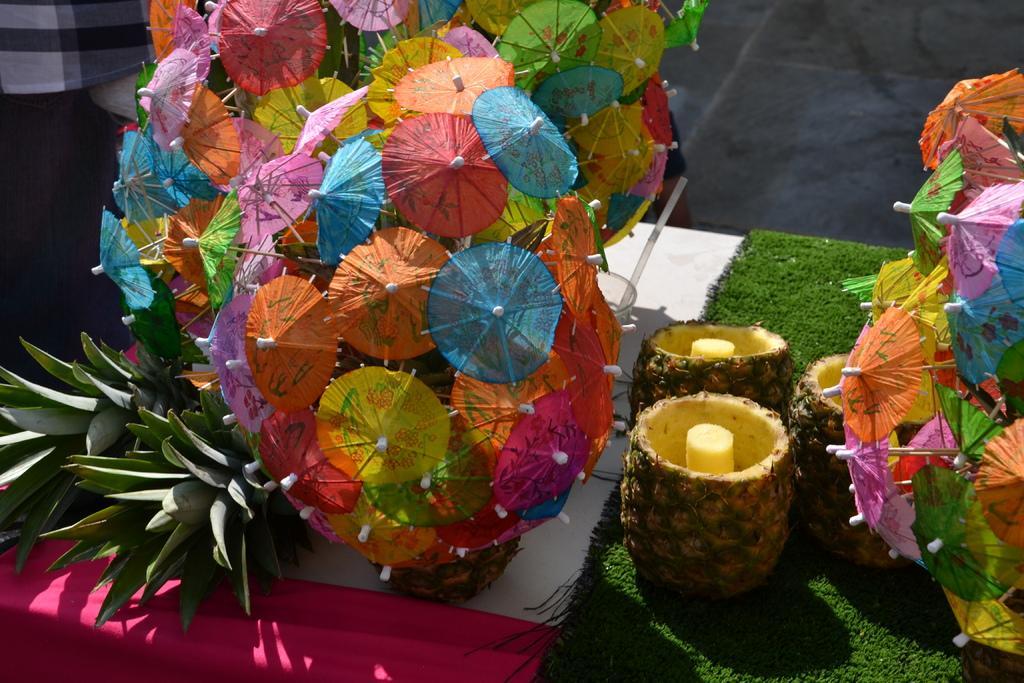Could you give a brief overview of what you see in this image? In this image we can see the table and on the table we can see the paper umbrellas and also the pineapples. We can also see the green color mat. In the background we can see the path. We can also see a person standing on the left. 